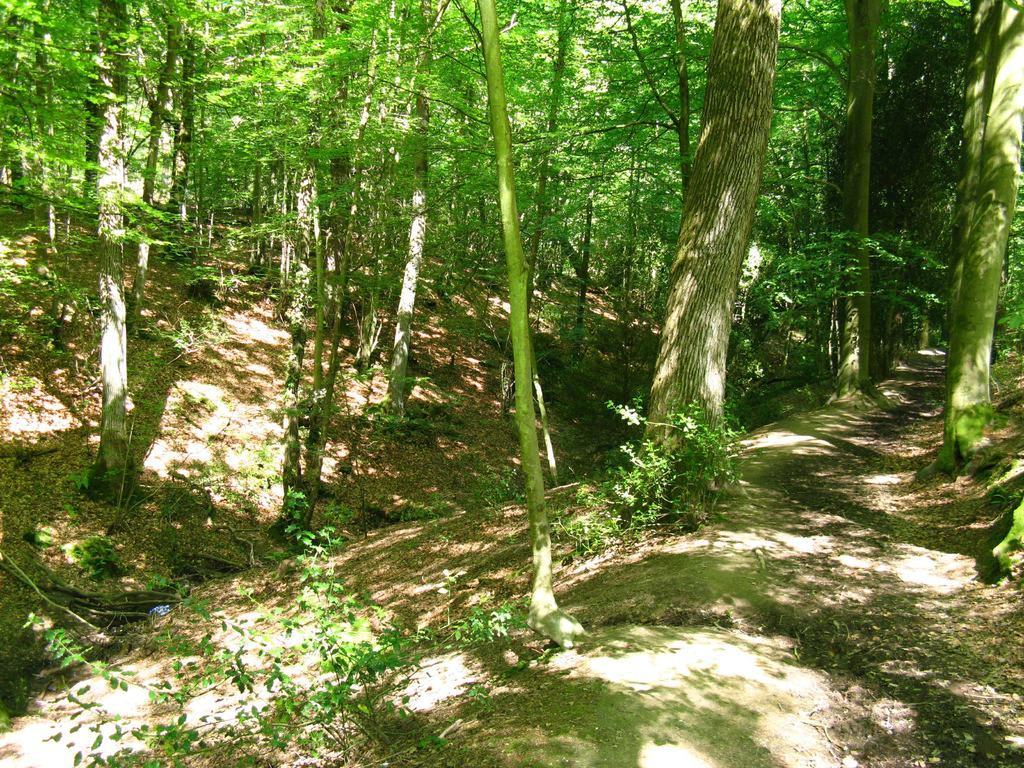What type of vegetation can be seen in the image? There are trees in the image. How are the trees distributed in the land? The trees are spread all over the land. What type of string is being used to create a plate in the image? There is no string or plate present in the image; it features trees spread all over the land. Where is the playground located in the image? There is no playground present in the image; it features trees spread all over the land. 